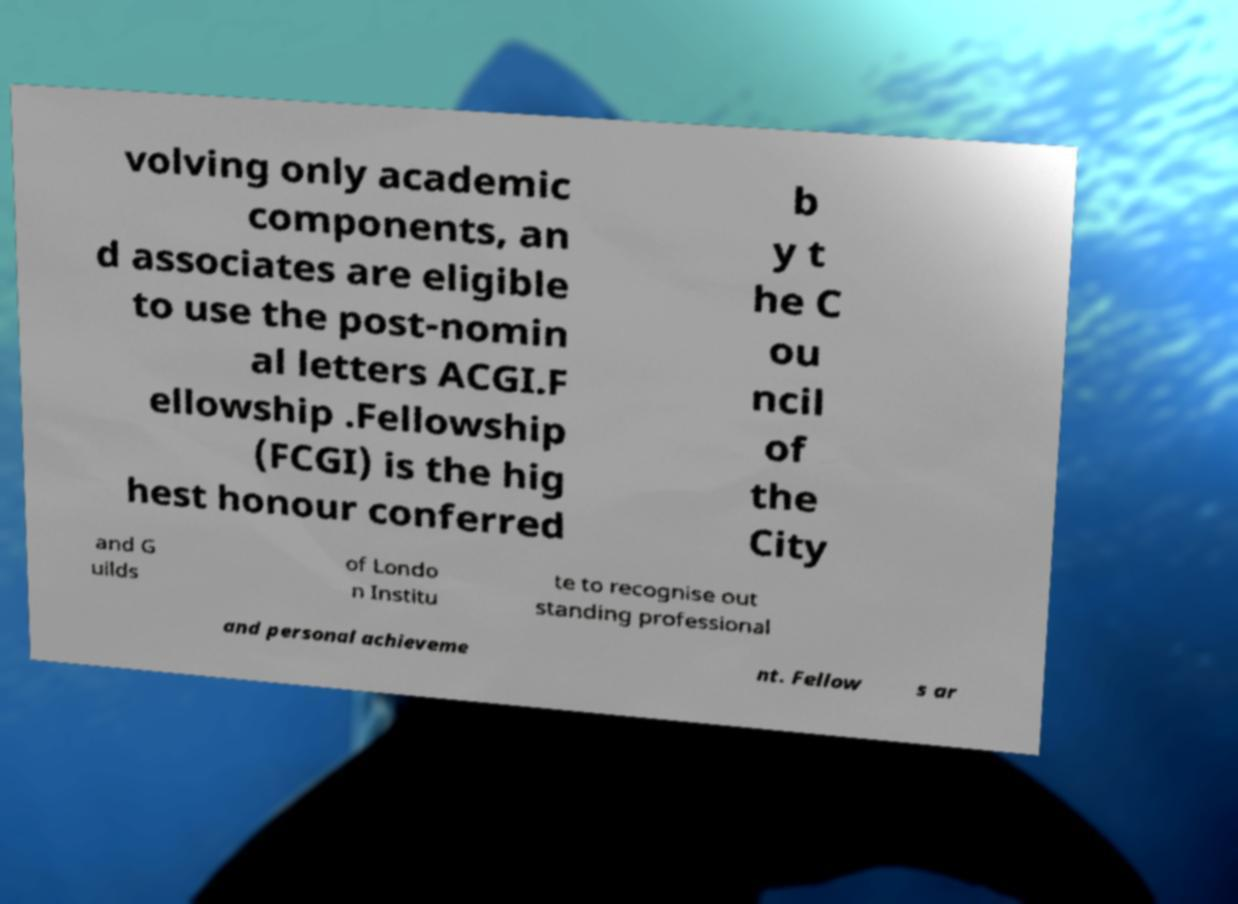Please read and relay the text visible in this image. What does it say? volving only academic components, an d associates are eligible to use the post-nomin al letters ACGI.F ellowship .Fellowship (FCGI) is the hig hest honour conferred b y t he C ou ncil of the City and G uilds of Londo n Institu te to recognise out standing professional and personal achieveme nt. Fellow s ar 